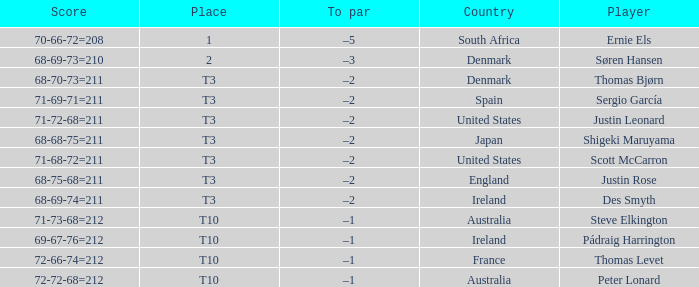What player scored 71-69-71=211? Sergio García. 